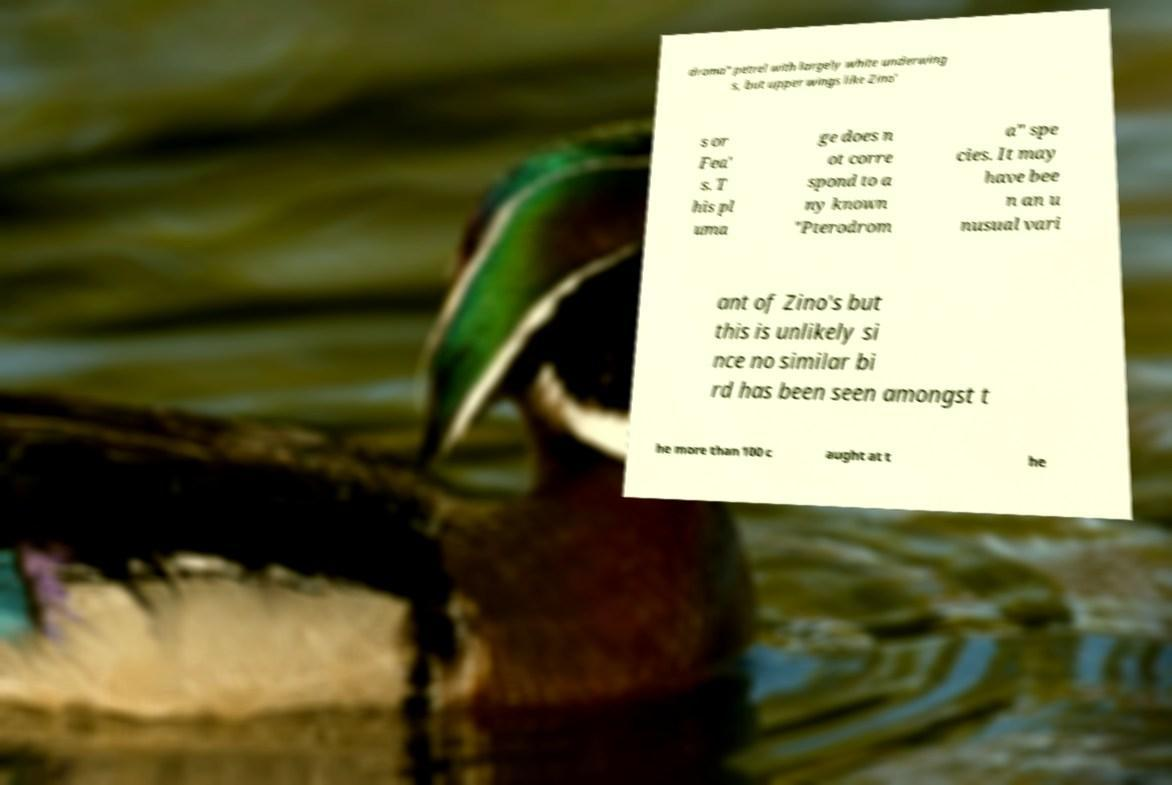Can you read and provide the text displayed in the image?This photo seems to have some interesting text. Can you extract and type it out for me? droma" petrel with largely white underwing s, but upper wings like Zino' s or Fea' s. T his pl uma ge does n ot corre spond to a ny known "Pterodrom a" spe cies. It may have bee n an u nusual vari ant of Zino's but this is unlikely si nce no similar bi rd has been seen amongst t he more than 100 c aught at t he 